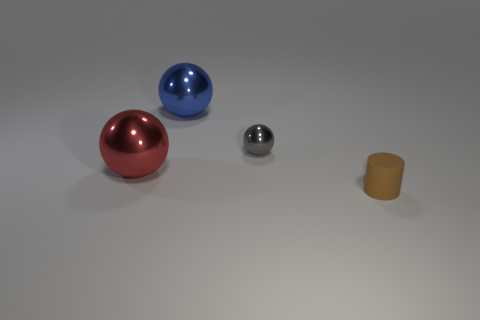There is a gray thing that is made of the same material as the big blue thing; what size is it?
Give a very brief answer. Small. Does the ball that is in front of the gray sphere have the same material as the thing that is on the right side of the tiny gray metallic ball?
Your response must be concise. No. What number of blocks are tiny gray objects or small brown things?
Your response must be concise. 0. There is a large metal sphere in front of the metallic ball behind the gray ball; what number of small matte cylinders are to the left of it?
Make the answer very short. 0. What is the material of the red thing that is the same shape as the gray object?
Your answer should be compact. Metal. Are there any other things that have the same material as the small cylinder?
Give a very brief answer. No. What color is the metal thing that is behind the small gray object?
Make the answer very short. Blue. Do the tiny brown thing and the large ball that is on the right side of the red metal thing have the same material?
Provide a short and direct response. No. What is the material of the brown thing?
Offer a terse response. Rubber. There is a blue object that is the same material as the tiny gray ball; what shape is it?
Your answer should be compact. Sphere. 